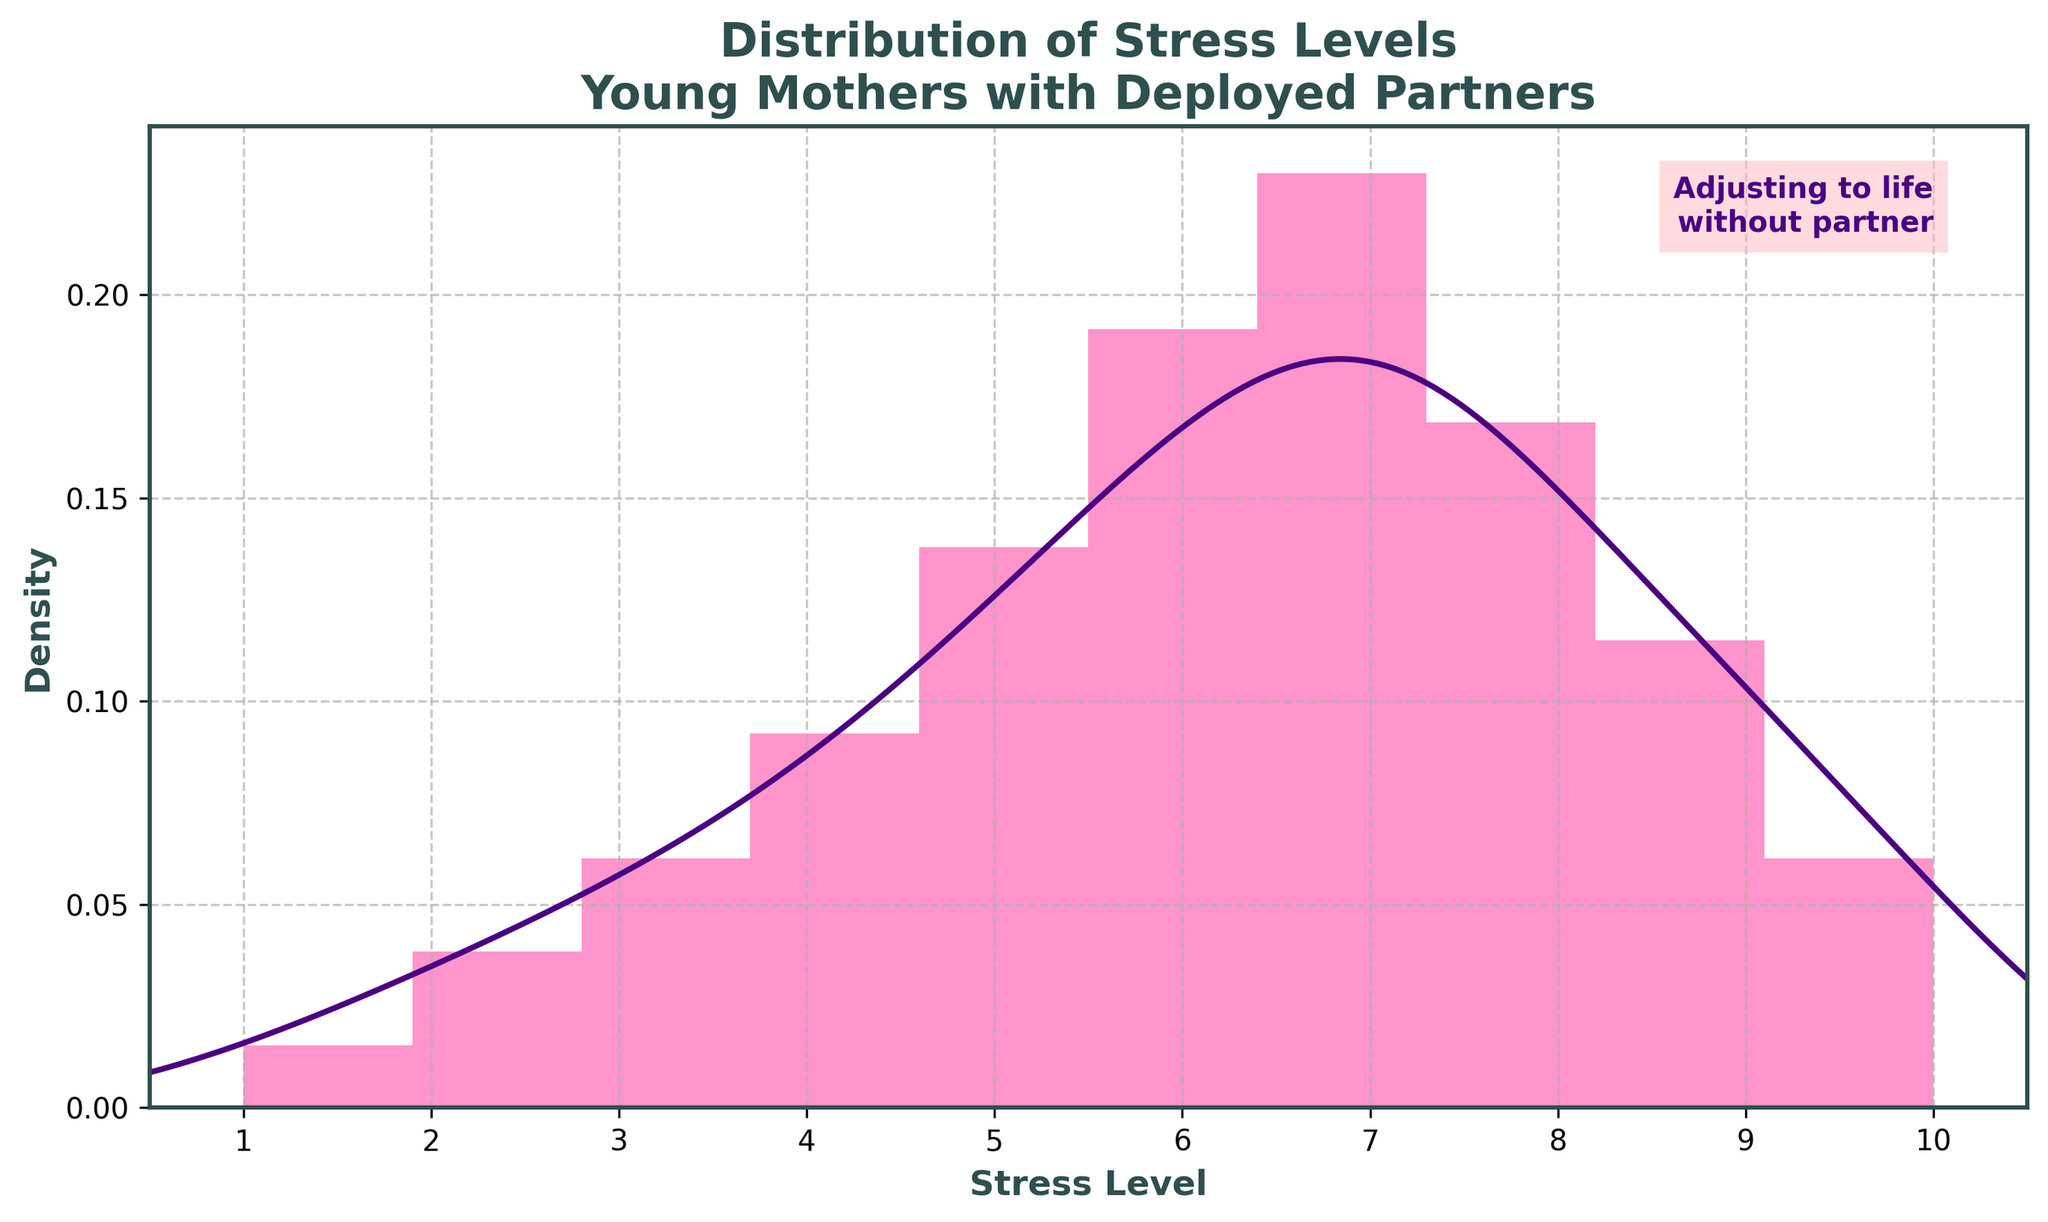What is the title of the figure? The plot title is usually located at the top center of the figure. In this case, it reads "Distribution of Stress Levels\nYoung Mothers with Deployed Partners," indicating the data it represents.
Answer: Distribution of Stress Levels\nYoung Mothers with Deployed Partners What colors are used in the plot? The histogram bars are colored pinkish (likely '#FF69B4') and the KDE line is a deep purple color (likely '#4B0082'). These colors help differentiate between the histogram and the density curve.
Answer: Pink and purple What is the stress level with the highest density? By closely examining the peak of the KDE (density) curve, we can identify the stress level with the highest density. This peak occurs around the stress level of 7.
Answer: 7 How does the density behavior change from stress level 1 to 10? The density curve (KDE) starts low at level 1, increases and peaks around level 7, and then declines towards level 10. This indicates that stress levels around 7 are the most frequent among the group.
Answer: Increases then decreases Which stress levels have lower densities compared to the peak? By observing the KDE curve, we can see that stress levels at the lower end (like 1 and 2) and higher end (like 9 and 10) have densities lower than the peak at around level 7.
Answer: 1, 2, 9, 10 Is the density distributed symmetrically around the peak? The density curve is not symmetric around the peak. It rises more steeply before level 7 and falls more gradually after, indicating a skewed distribution.
Answer: No What is the sum of the frequencies of stress levels from 2 to 5? Adding the frequencies for levels 2 (5), 3 (8), 4 (12), and 5 (18) gives 5 + 8 + 12 + 18. This totals to 43.
Answer: 43 Compare the density around stress level 5 and 9. Which is higher? By looking at the KDE curve, the density around stress level 5 is higher compared to stress level 9. This indicates more frequent reports of stress level 5.
Answer: Stress level 5 What does the annotation in the figure say? The annotation in the top right corner reads "Adjusting to life\nwithout partner," reinforcing the context of the data being analyzed.
Answer: Adjusting to life\nwithout partner 